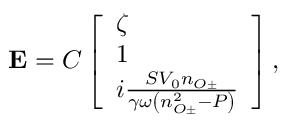Convert formula to latex. <formula><loc_0><loc_0><loc_500><loc_500>{ E } = C \left [ \begin{array} { l } { \zeta } \\ { 1 } \\ { i \frac { S V _ { 0 } n _ { O \pm } } { \gamma \omega \left ( n _ { O \pm } ^ { 2 } - P \right ) } } \end{array} \right ] ,</formula> 